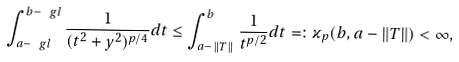<formula> <loc_0><loc_0><loc_500><loc_500>\int ^ { b - \ g l } _ { a - \ g l } \frac { 1 } { ( t ^ { 2 } + y ^ { 2 } ) ^ { p / 4 } } d t \leq \int ^ { b } _ { a - \| T \| } \frac { 1 } { t ^ { p / 2 } } d t = \colon \varkappa _ { p } ( b , a - \| T \| ) < \infty ,</formula> 